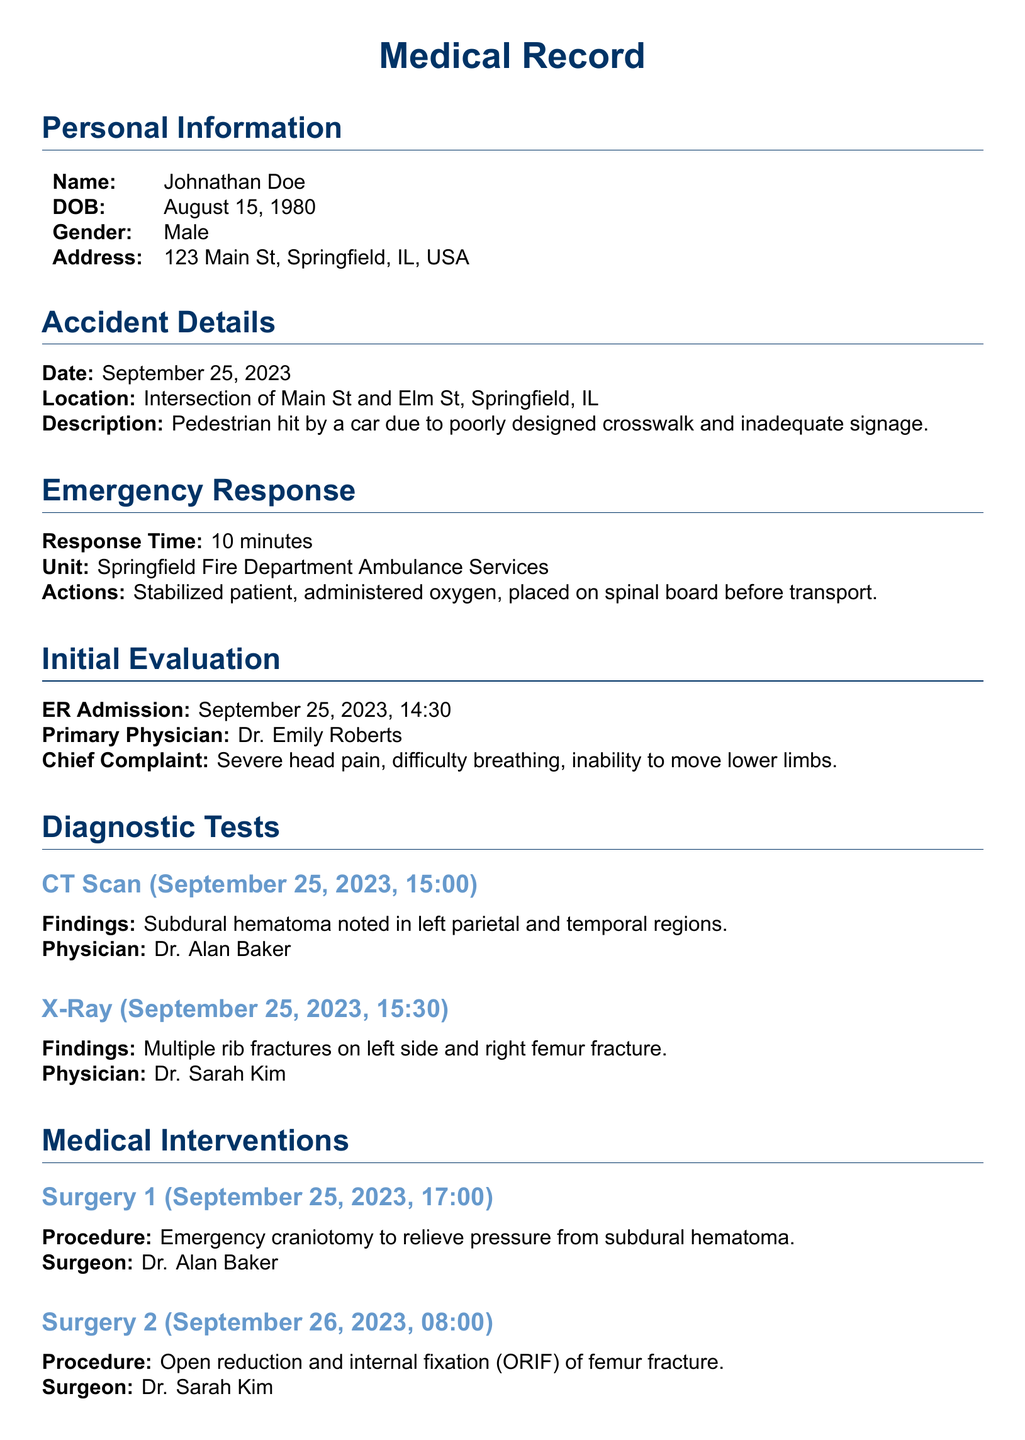What is the name of the patient? The patient's name is listed in the personal information section of the document.
Answer: Johnathan Doe What was the primary complaint upon ER admission? The chief complaint is noted in the initial evaluation section of the document.
Answer: Severe head pain What was the date of the accident? The date is provided in the accident details section of the document.
Answer: September 25, 2023 Which physician conducted the initial evaluation? The name of the physician is included in the initial evaluation section.
Answer: Dr. Emily Roberts What type of surgery was performed at 17:00 on September 25, 2023? The procedure is outlined in the medical interventions section of the document.
Answer: Emergency craniotomy What findings were noted in the CT scan? The findings are specified in the diagnostic tests section of the document.
Answer: Subdural hematoma How many follow-up appointments are listed, and when is the last one? The follow-up appointments are detailed in the follow-up care section.
Answer: Two; October 12, 2023 What type of therapy is scheduled to start on October 10, 2023? The type of therapy is mentioned in the follow-up care section of the document.
Answer: Physical Therapy Who is the legal representative mentioned in the document? The legal representation is noted in the legal considerations section.
Answer: Attorney David Johnson 